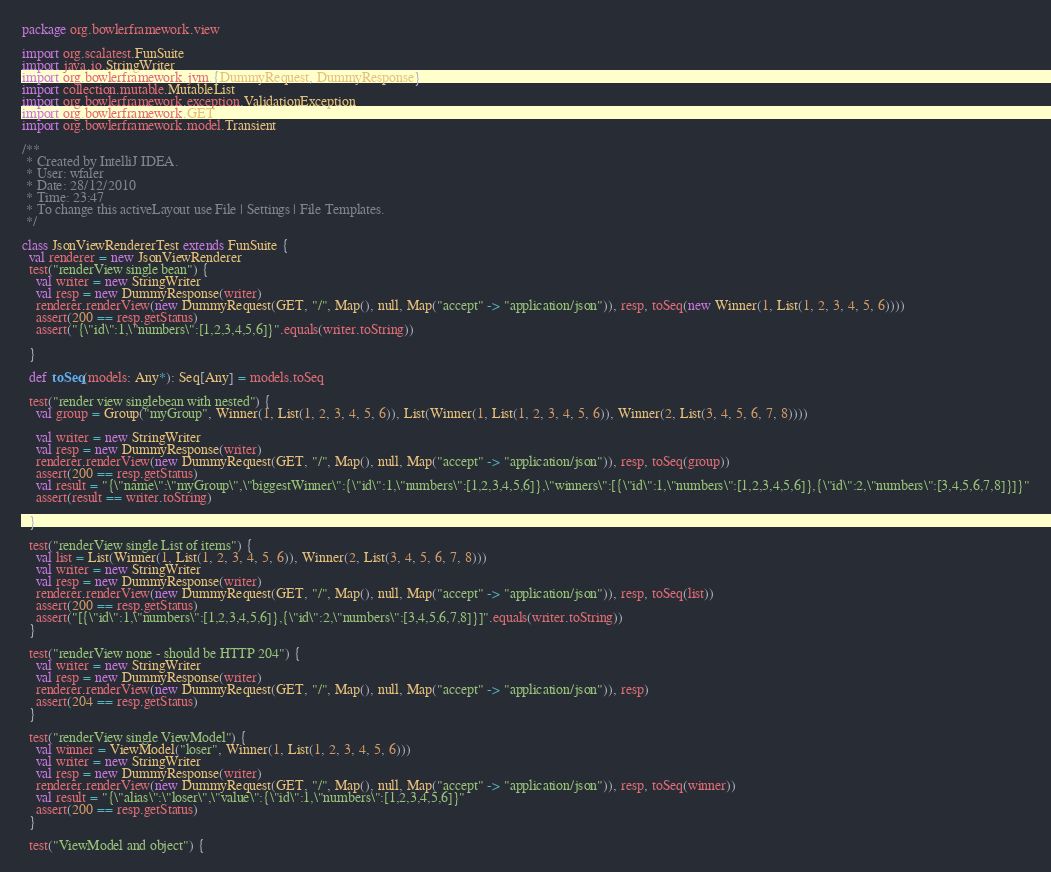<code> <loc_0><loc_0><loc_500><loc_500><_Scala_>package org.bowlerframework.view

import org.scalatest.FunSuite
import java.io.StringWriter
import org.bowlerframework.jvm.{DummyRequest, DummyResponse}
import collection.mutable.MutableList
import org.bowlerframework.exception.ValidationException
import org.bowlerframework.GET
import org.bowlerframework.model.Transient

/**
 * Created by IntelliJ IDEA.
 * User: wfaler
 * Date: 28/12/2010
 * Time: 23:47
 * To change this activeLayout use File | Settings | File Templates.
 */

class JsonViewRendererTest extends FunSuite {
  val renderer = new JsonViewRenderer
  test("renderView single bean") {
    val writer = new StringWriter
    val resp = new DummyResponse(writer)
    renderer.renderView(new DummyRequest(GET, "/", Map(), null, Map("accept" -> "application/json")), resp, toSeq(new Winner(1, List(1, 2, 3, 4, 5, 6))))
    assert(200 == resp.getStatus)
    assert("{\"id\":1,\"numbers\":[1,2,3,4,5,6]}".equals(writer.toString))

  }

  def toSeq(models: Any*): Seq[Any] = models.toSeq

  test("render view singlebean with nested") {
    val group = Group("myGroup", Winner(1, List(1, 2, 3, 4, 5, 6)), List(Winner(1, List(1, 2, 3, 4, 5, 6)), Winner(2, List(3, 4, 5, 6, 7, 8))))

    val writer = new StringWriter
    val resp = new DummyResponse(writer)
    renderer.renderView(new DummyRequest(GET, "/", Map(), null, Map("accept" -> "application/json")), resp, toSeq(group))
    assert(200 == resp.getStatus)
    val result = "{\"name\":\"myGroup\",\"biggestWinner\":{\"id\":1,\"numbers\":[1,2,3,4,5,6]},\"winners\":[{\"id\":1,\"numbers\":[1,2,3,4,5,6]},{\"id\":2,\"numbers\":[3,4,5,6,7,8]}]}"
    assert(result == writer.toString)

  }

  test("renderView single List of items") {
    val list = List(Winner(1, List(1, 2, 3, 4, 5, 6)), Winner(2, List(3, 4, 5, 6, 7, 8)))
    val writer = new StringWriter
    val resp = new DummyResponse(writer)
    renderer.renderView(new DummyRequest(GET, "/", Map(), null, Map("accept" -> "application/json")), resp, toSeq(list))
    assert(200 == resp.getStatus)
    assert("[{\"id\":1,\"numbers\":[1,2,3,4,5,6]},{\"id\":2,\"numbers\":[3,4,5,6,7,8]}]".equals(writer.toString))
  }

  test("renderView none - should be HTTP 204") {
    val writer = new StringWriter
    val resp = new DummyResponse(writer)
    renderer.renderView(new DummyRequest(GET, "/", Map(), null, Map("accept" -> "application/json")), resp)
    assert(204 == resp.getStatus)
  }

  test("renderView single ViewModel") {
    val winner = ViewModel("loser", Winner(1, List(1, 2, 3, 4, 5, 6)))
    val writer = new StringWriter
    val resp = new DummyResponse(writer)
    renderer.renderView(new DummyRequest(GET, "/", Map(), null, Map("accept" -> "application/json")), resp, toSeq(winner))
    val result = "{\"alias\":\"loser\",\"value\":{\"id\":1,\"numbers\":[1,2,3,4,5,6]}"
    assert(200 == resp.getStatus)
  }

  test("ViewModel and object") {</code> 